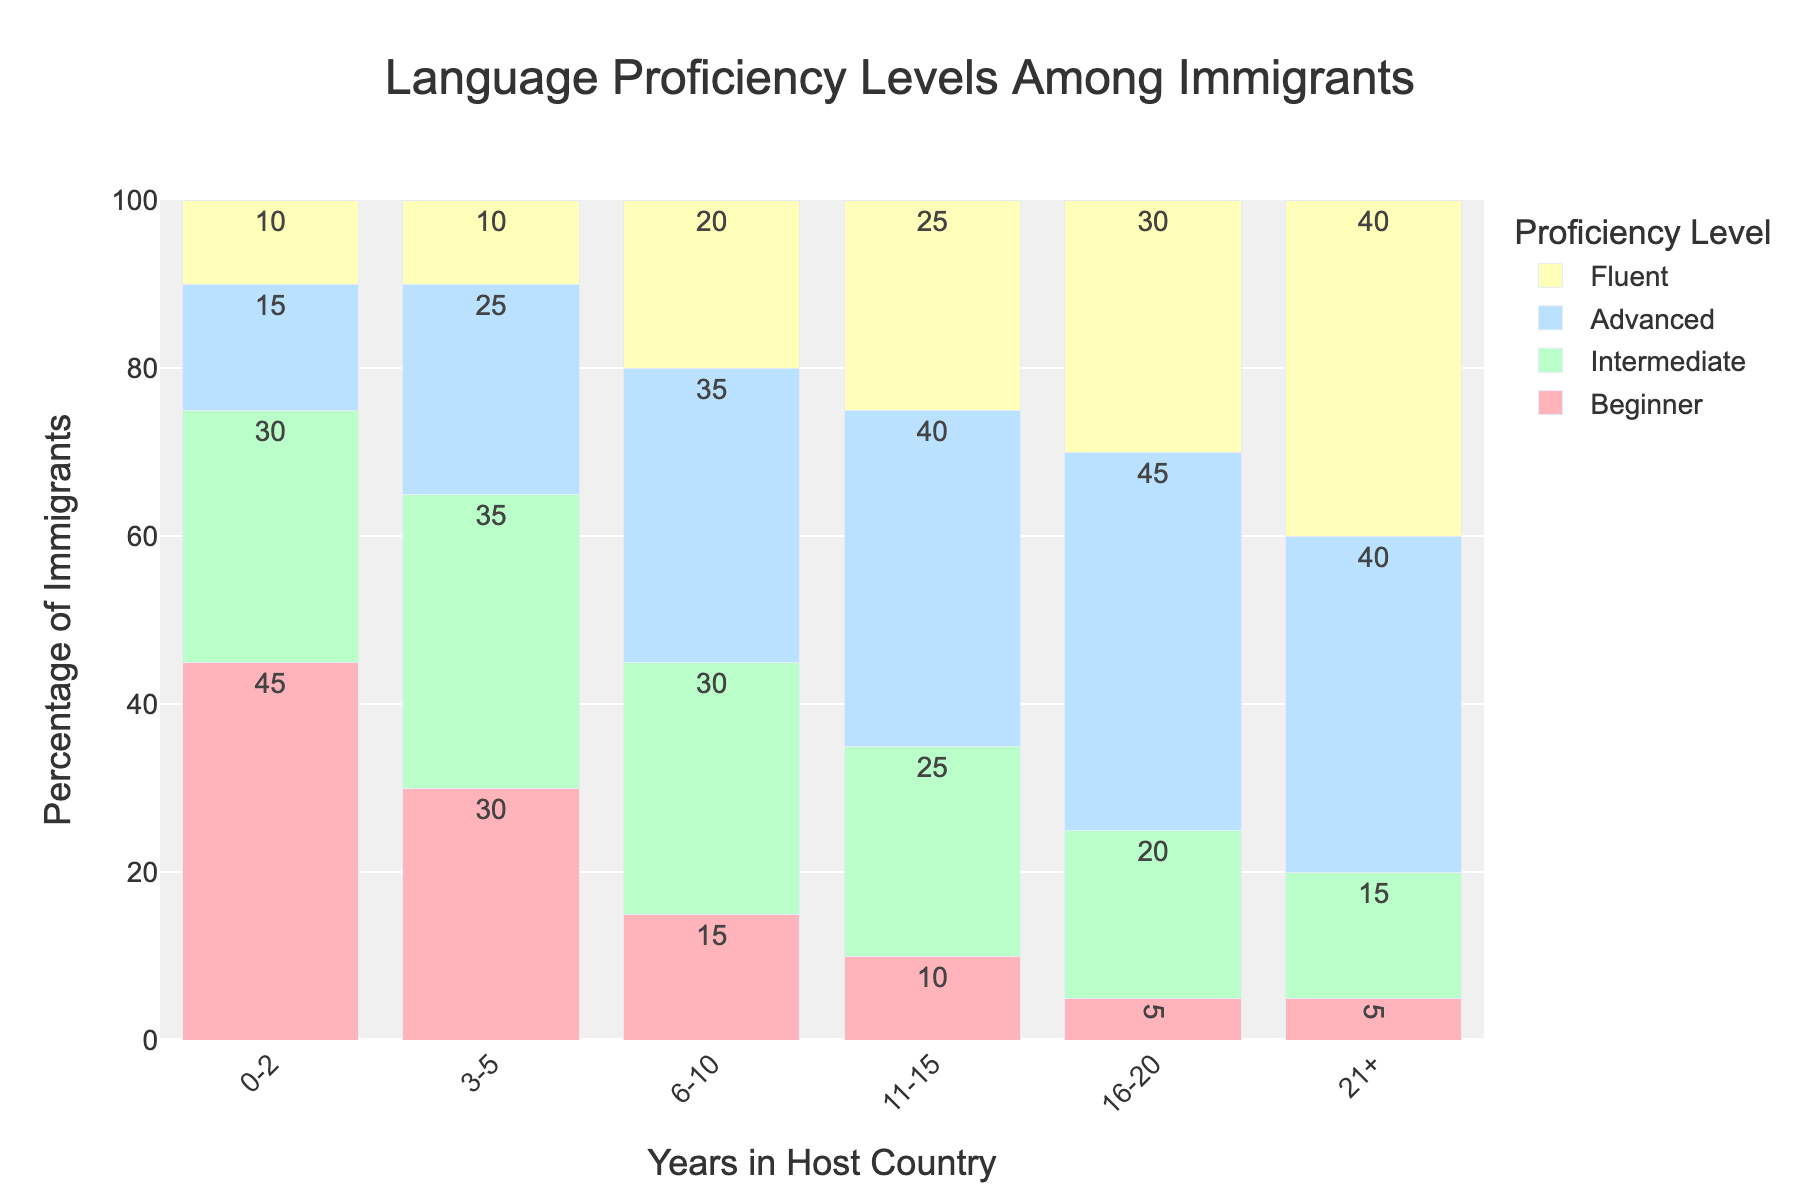Which proficiency level has the highest percentage among immigrants who have been in the host country for 21 or more years? Observe the highest bar for each proficiency level in the final group. The "Fluent" level has the highest bar.
Answer: Fluent How does the percentage of "Intermediate" proficiency change from 0-2 years to 16-20 years? Start by noting the percentage values of the "Intermediate" level for the two groups: it's 30% for 0-2 years and 20% for 16-20 years. Subtract the second value from the first: 30% - 20% = 10%.
Answer: Decreases by 10% What is the total percentage of immigrants with "Advanced" proficiency who have been in the host country for up to 10 years? Sum the percentages for the "Advanced" level for the 0-2 years, 3-5 years, and 6-10 years groups: 15% + 25% + 35% = 75%.
Answer: 75% Which group has more "Fluent" speakers, 6-10 years or 16-20 years in the host country? Compare the bars for the "Fluent" level: 20% for 6-10 years and 30% for 16-20 years.
Answer: 16-20 years How does the percentage of "Beginner" proficiency change from 0-2 years to 21+ years? Start by noting the percentage values of the "Beginner" level for the two groups: it's 45% for 0-2 years and 5% for 21+ years. Subtract the second value from the first: 45% - 5% = 40%.
Answer: Decreases by 40% In which year group does the "Advanced" proficiency level first surpass the "Beginner" proficiency level? Observe each group: "Advanced" first surpasses "Beginner" in the 6-10 years group (35% > 15%).
Answer: 6-10 years Is the percentage of "Fluent" speakers higher than "Beginner" speakers in the 3-5 years group? Compare the bars for "Fluent" (10%) and "Beginner" (30%) in the 3-5 years group: 10% < 30%.
Answer: No What is the combined percentage of "Advanced" and "Fluent" speakers in the 11-15 years group? Sum the percentages for "Advanced" and "Fluent" in the 11-15 years group: 40% + 25% = 65%.
Answer: 65% Which proficiency level shows the highest percentage increase between 0-2 years and 6-10 years? Calculate the percentage increase for each proficiency level between 0-2 years and 6-10 years:
- Beginner: 45% to 15% (decrease)
- Intermediate: 30% to 30% (no change)
- Advanced: 15% to 35% (20% increase)
- Fluent: 10% to 20% (10% increase)
"Advanced" shows the highest increase (20%).
Answer: Advanced In the 21+ years group, which proficiency levels have approximately equal percentages? Observe the bars: "Advanced" (40%) and "Fluent" (40%) have approximately equal percentages in the 21+ years group.
Answer: Advanced and Fluent 